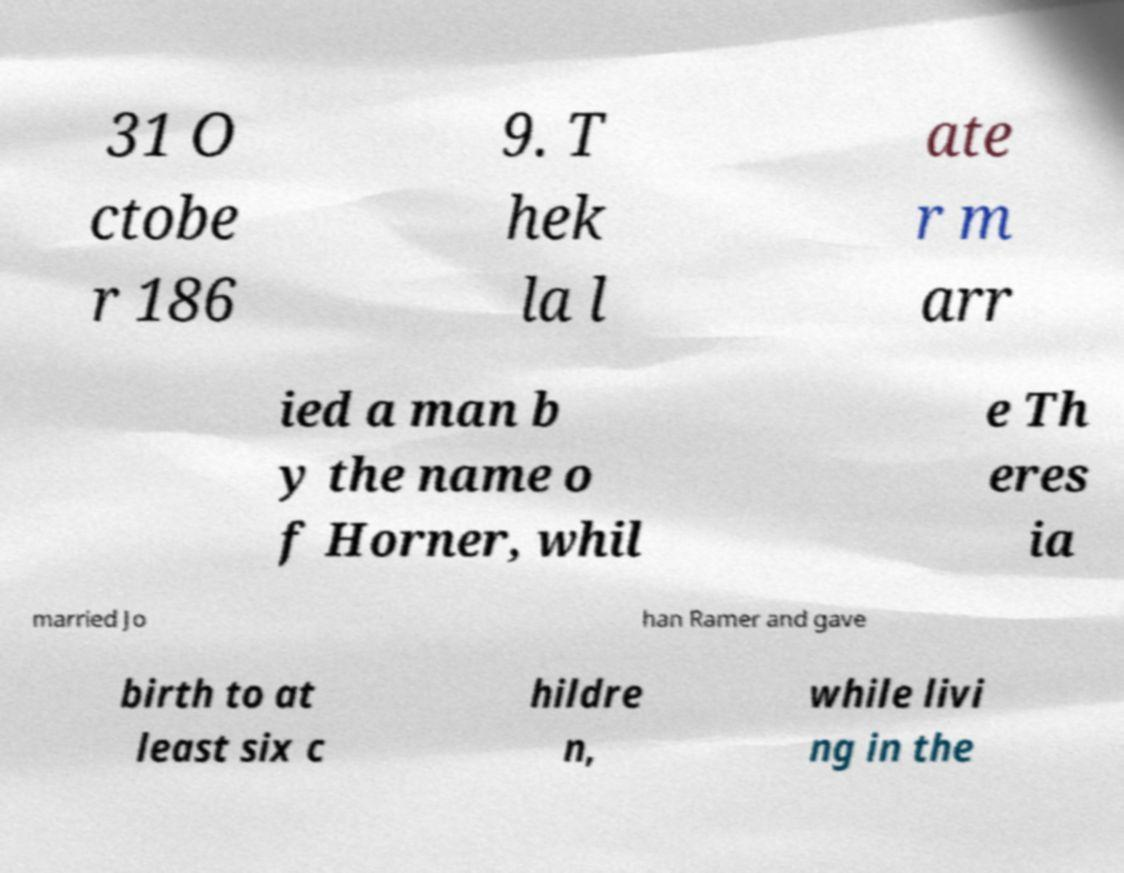What messages or text are displayed in this image? I need them in a readable, typed format. 31 O ctobe r 186 9. T hek la l ate r m arr ied a man b y the name o f Horner, whil e Th eres ia married Jo han Ramer and gave birth to at least six c hildre n, while livi ng in the 